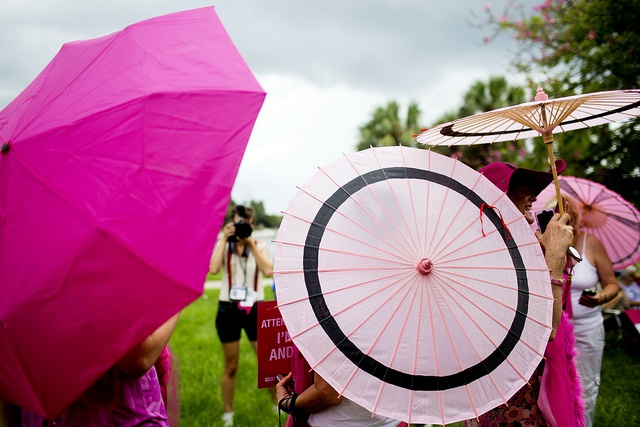Describe the objects in this image and their specific colors. I can see umbrella in lightgray, magenta, purple, and maroon tones, umbrella in lightgray, lavender, pink, lightpink, and black tones, people in lightgray, black, maroon, darkgray, and brown tones, umbrella in lightgray, lavender, tan, black, and darkgreen tones, and people in lightgray, black, maroon, and purple tones in this image. 